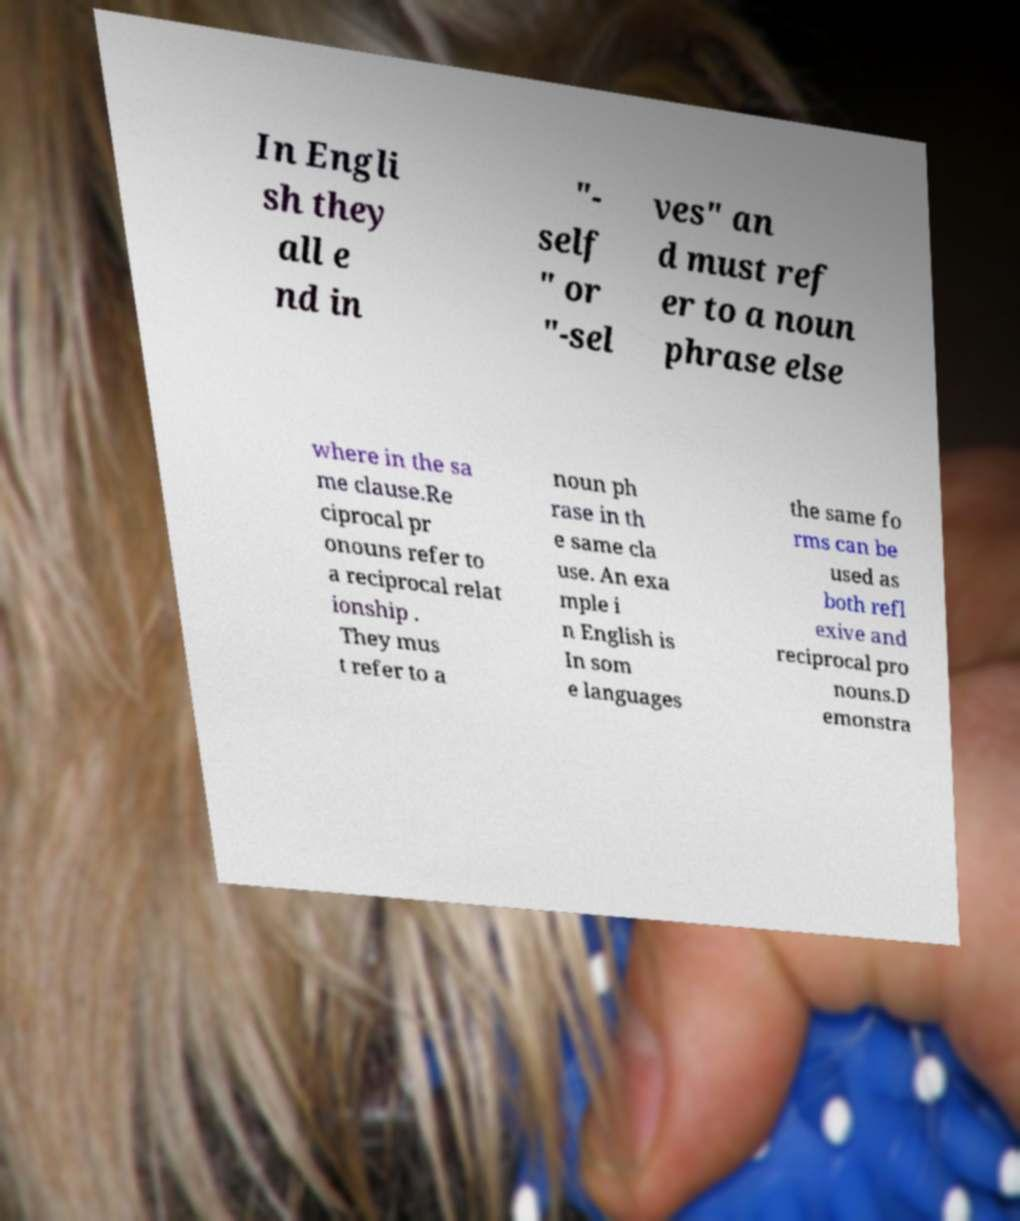I need the written content from this picture converted into text. Can you do that? In Engli sh they all e nd in "- self " or "-sel ves" an d must ref er to a noun phrase else where in the sa me clause.Re ciprocal pr onouns refer to a reciprocal relat ionship . They mus t refer to a noun ph rase in th e same cla use. An exa mple i n English is In som e languages the same fo rms can be used as both refl exive and reciprocal pro nouns.D emonstra 